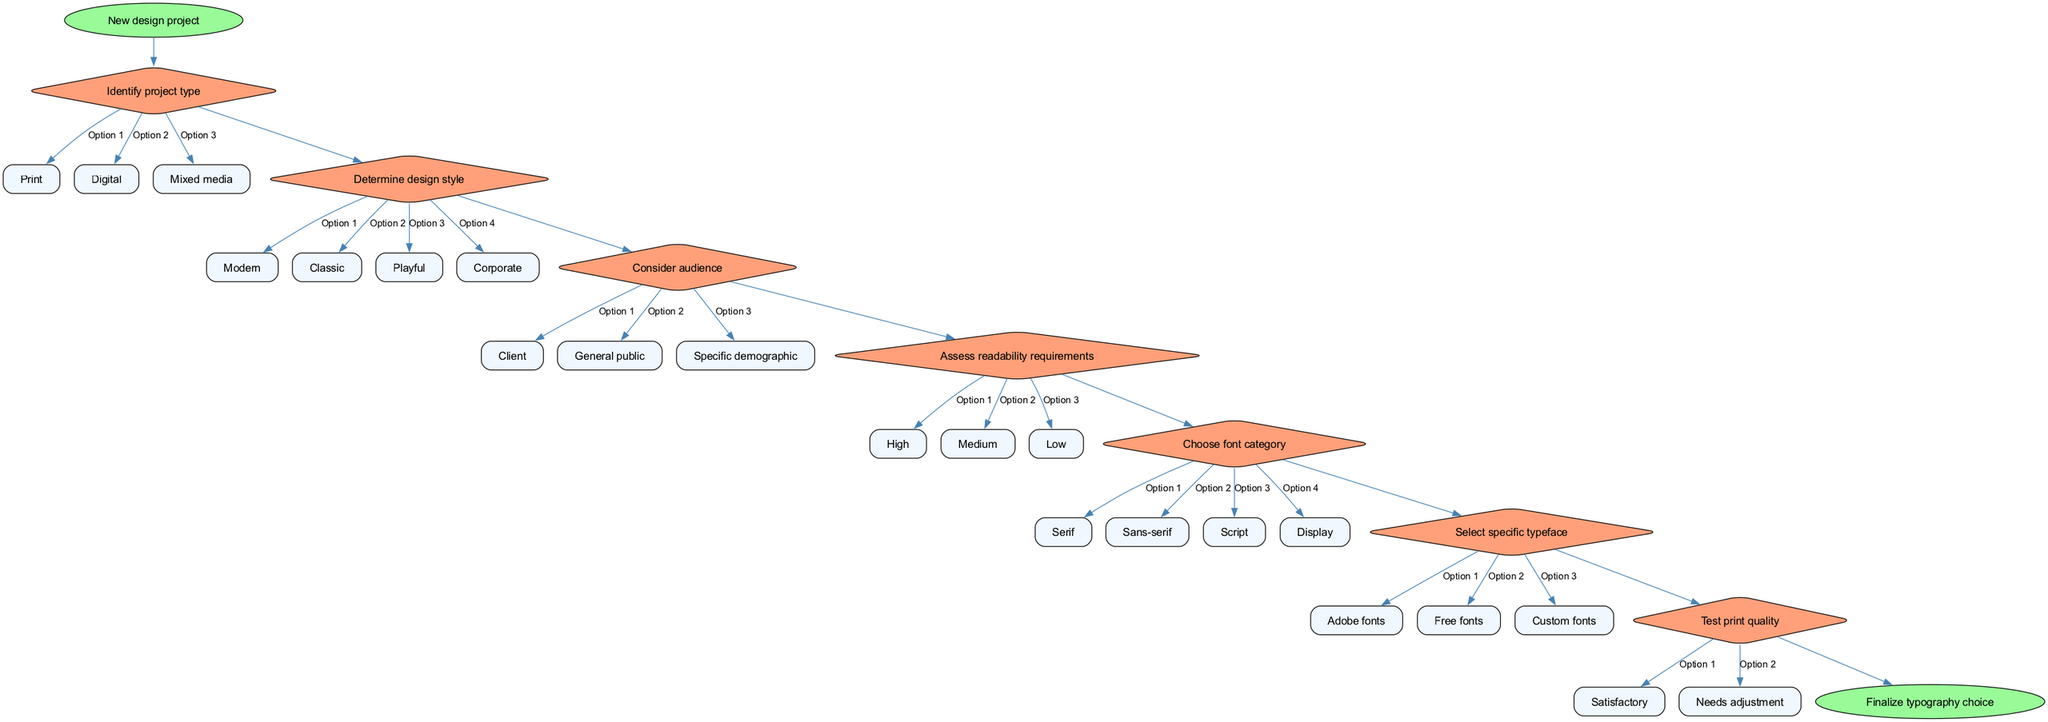What is the starting node of the flow chart? The starting node is labeled "New design project", which is the first node in the diagram.
Answer: New design project How many options are available after identifying the project type? The "Identify project type" decision node has three options listed: Print, Digital, and Mixed media, making a total of three options available.
Answer: Three Which decision node follows "Identify project type"? The second decision node is "Determine design style", which directly follows the "Identify project type" node in the flow sequence.
Answer: Determine design style What option is chosen if the audience is a specific demographic? If the audience is specified as "Specific demographic", it leads to the next part of the flow sequence based on that option.
Answer: Specific demographic What is the last decision point before finalizing typography choice? The last decision point is "Test print quality", which is before reaching the "Finalize typography choice".
Answer: Test print quality How many decision nodes are present in the flow chart? There are seven decision nodes present in the flow chart, each representing a step in the decision-making process.
Answer: Seven Which font category is chosen when readability requirements are high? If readability requirements are assessed as "High", the decision leads to choosing a relevant font category, but the specific category is not defined here.
Answer: Not defined What is the color of the start node? The start node "New design project" is filled with a shade of green, specifically indicated as #98FB98 in the diagram.
Answer: Green How does the flow progress after determining the design style? After determining the design style, the flow progresses to the next decision, which is to consider the audience, connecting the nodes sequentially.
Answer: Consider audience 